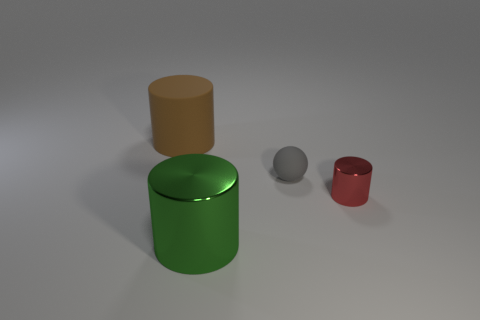The small object that is made of the same material as the big green thing is what color?
Keep it short and to the point. Red. What material is the large cylinder that is on the left side of the big metallic object right of the big cylinder behind the tiny ball?
Keep it short and to the point. Rubber. Is the size of the cylinder that is on the left side of the green cylinder the same as the small rubber object?
Your answer should be compact. No. How many small objects are green things or brown matte things?
Make the answer very short. 0. Is there a rubber cylinder that has the same color as the big matte thing?
Offer a very short reply. No. There is another thing that is the same size as the red shiny object; what is its shape?
Keep it short and to the point. Sphere. There is a rubber object on the right side of the large brown thing; is it the same color as the large matte cylinder?
Make the answer very short. No. What number of things are either large objects in front of the brown cylinder or large green cylinders?
Offer a terse response. 1. Is the number of red objects that are in front of the red cylinder greater than the number of tiny red shiny things that are right of the big green metallic cylinder?
Give a very brief answer. No. Are the big brown cylinder and the green cylinder made of the same material?
Your answer should be very brief. No. 